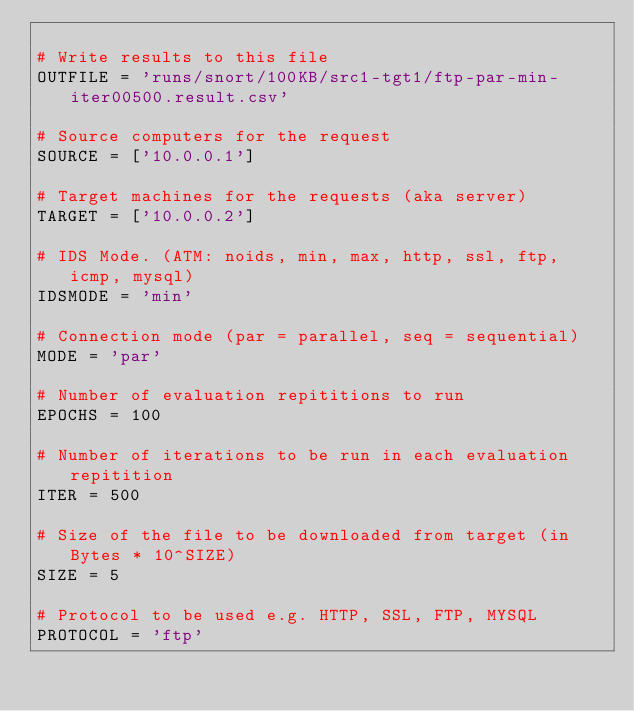Convert code to text. <code><loc_0><loc_0><loc_500><loc_500><_Python_>
# Write results to this file
OUTFILE = 'runs/snort/100KB/src1-tgt1/ftp-par-min-iter00500.result.csv'

# Source computers for the request
SOURCE = ['10.0.0.1']

# Target machines for the requests (aka server)
TARGET = ['10.0.0.2']

# IDS Mode. (ATM: noids, min, max, http, ssl, ftp, icmp, mysql)
IDSMODE = 'min'

# Connection mode (par = parallel, seq = sequential)
MODE = 'par'

# Number of evaluation repititions to run
EPOCHS = 100

# Number of iterations to be run in each evaluation repitition
ITER = 500

# Size of the file to be downloaded from target (in Bytes * 10^SIZE)
SIZE = 5

# Protocol to be used e.g. HTTP, SSL, FTP, MYSQL
PROTOCOL = 'ftp'</code> 